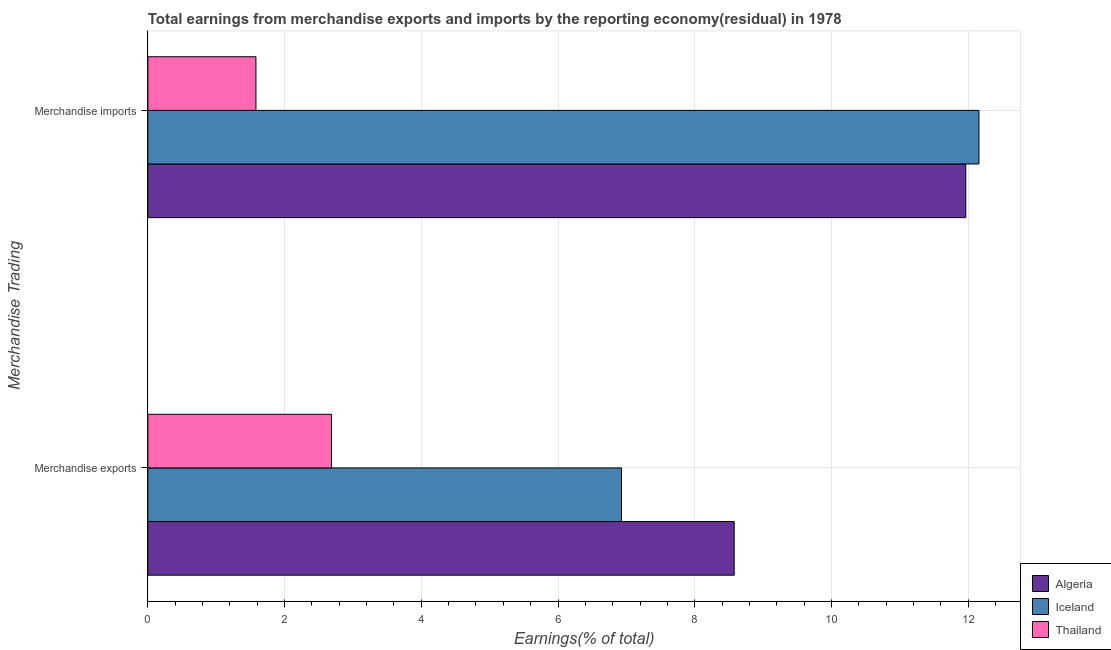How many groups of bars are there?
Give a very brief answer. 2. Are the number of bars per tick equal to the number of legend labels?
Provide a short and direct response. Yes. Are the number of bars on each tick of the Y-axis equal?
Give a very brief answer. Yes. What is the label of the 1st group of bars from the top?
Your answer should be compact. Merchandise imports. What is the earnings from merchandise exports in Algeria?
Offer a terse response. 8.58. Across all countries, what is the maximum earnings from merchandise imports?
Keep it short and to the point. 12.16. Across all countries, what is the minimum earnings from merchandise imports?
Your answer should be compact. 1.58. In which country was the earnings from merchandise imports maximum?
Your answer should be compact. Iceland. In which country was the earnings from merchandise imports minimum?
Ensure brevity in your answer.  Thailand. What is the total earnings from merchandise exports in the graph?
Offer a very short reply. 18.19. What is the difference between the earnings from merchandise imports in Iceland and that in Thailand?
Offer a terse response. 10.58. What is the difference between the earnings from merchandise exports in Thailand and the earnings from merchandise imports in Algeria?
Keep it short and to the point. -9.28. What is the average earnings from merchandise exports per country?
Your response must be concise. 6.06. What is the difference between the earnings from merchandise imports and earnings from merchandise exports in Algeria?
Provide a succinct answer. 3.39. In how many countries, is the earnings from merchandise exports greater than 0.4 %?
Make the answer very short. 3. What is the ratio of the earnings from merchandise exports in Thailand to that in Iceland?
Make the answer very short. 0.39. What does the 3rd bar from the top in Merchandise imports represents?
Your answer should be compact. Algeria. What does the 3rd bar from the bottom in Merchandise exports represents?
Your answer should be compact. Thailand. Are all the bars in the graph horizontal?
Your response must be concise. Yes. What is the difference between two consecutive major ticks on the X-axis?
Offer a very short reply. 2. Are the values on the major ticks of X-axis written in scientific E-notation?
Make the answer very short. No. Does the graph contain any zero values?
Your answer should be compact. No. Does the graph contain grids?
Your response must be concise. Yes. What is the title of the graph?
Give a very brief answer. Total earnings from merchandise exports and imports by the reporting economy(residual) in 1978. What is the label or title of the X-axis?
Your answer should be compact. Earnings(% of total). What is the label or title of the Y-axis?
Ensure brevity in your answer.  Merchandise Trading. What is the Earnings(% of total) in Algeria in Merchandise exports?
Offer a very short reply. 8.58. What is the Earnings(% of total) of Iceland in Merchandise exports?
Offer a very short reply. 6.93. What is the Earnings(% of total) in Thailand in Merchandise exports?
Your answer should be compact. 2.69. What is the Earnings(% of total) in Algeria in Merchandise imports?
Your answer should be very brief. 11.97. What is the Earnings(% of total) of Iceland in Merchandise imports?
Your answer should be very brief. 12.16. What is the Earnings(% of total) in Thailand in Merchandise imports?
Offer a very short reply. 1.58. Across all Merchandise Trading, what is the maximum Earnings(% of total) of Algeria?
Give a very brief answer. 11.97. Across all Merchandise Trading, what is the maximum Earnings(% of total) in Iceland?
Make the answer very short. 12.16. Across all Merchandise Trading, what is the maximum Earnings(% of total) of Thailand?
Offer a very short reply. 2.69. Across all Merchandise Trading, what is the minimum Earnings(% of total) of Algeria?
Give a very brief answer. 8.58. Across all Merchandise Trading, what is the minimum Earnings(% of total) of Iceland?
Make the answer very short. 6.93. Across all Merchandise Trading, what is the minimum Earnings(% of total) in Thailand?
Offer a terse response. 1.58. What is the total Earnings(% of total) in Algeria in the graph?
Offer a very short reply. 20.54. What is the total Earnings(% of total) of Iceland in the graph?
Ensure brevity in your answer.  19.09. What is the total Earnings(% of total) in Thailand in the graph?
Ensure brevity in your answer.  4.27. What is the difference between the Earnings(% of total) in Algeria in Merchandise exports and that in Merchandise imports?
Keep it short and to the point. -3.39. What is the difference between the Earnings(% of total) of Iceland in Merchandise exports and that in Merchandise imports?
Ensure brevity in your answer.  -5.23. What is the difference between the Earnings(% of total) in Thailand in Merchandise exports and that in Merchandise imports?
Keep it short and to the point. 1.1. What is the difference between the Earnings(% of total) of Algeria in Merchandise exports and the Earnings(% of total) of Iceland in Merchandise imports?
Offer a very short reply. -3.58. What is the difference between the Earnings(% of total) of Algeria in Merchandise exports and the Earnings(% of total) of Thailand in Merchandise imports?
Make the answer very short. 7. What is the difference between the Earnings(% of total) in Iceland in Merchandise exports and the Earnings(% of total) in Thailand in Merchandise imports?
Ensure brevity in your answer.  5.35. What is the average Earnings(% of total) of Algeria per Merchandise Trading?
Provide a short and direct response. 10.27. What is the average Earnings(% of total) in Iceland per Merchandise Trading?
Give a very brief answer. 9.54. What is the average Earnings(% of total) of Thailand per Merchandise Trading?
Your response must be concise. 2.13. What is the difference between the Earnings(% of total) of Algeria and Earnings(% of total) of Iceland in Merchandise exports?
Offer a terse response. 1.65. What is the difference between the Earnings(% of total) in Algeria and Earnings(% of total) in Thailand in Merchandise exports?
Ensure brevity in your answer.  5.89. What is the difference between the Earnings(% of total) in Iceland and Earnings(% of total) in Thailand in Merchandise exports?
Your answer should be very brief. 4.24. What is the difference between the Earnings(% of total) in Algeria and Earnings(% of total) in Iceland in Merchandise imports?
Your answer should be very brief. -0.19. What is the difference between the Earnings(% of total) of Algeria and Earnings(% of total) of Thailand in Merchandise imports?
Your answer should be very brief. 10.38. What is the difference between the Earnings(% of total) in Iceland and Earnings(% of total) in Thailand in Merchandise imports?
Your response must be concise. 10.58. What is the ratio of the Earnings(% of total) of Algeria in Merchandise exports to that in Merchandise imports?
Make the answer very short. 0.72. What is the ratio of the Earnings(% of total) in Iceland in Merchandise exports to that in Merchandise imports?
Offer a terse response. 0.57. What is the ratio of the Earnings(% of total) of Thailand in Merchandise exports to that in Merchandise imports?
Provide a short and direct response. 1.7. What is the difference between the highest and the second highest Earnings(% of total) of Algeria?
Offer a very short reply. 3.39. What is the difference between the highest and the second highest Earnings(% of total) of Iceland?
Your answer should be compact. 5.23. What is the difference between the highest and the second highest Earnings(% of total) in Thailand?
Keep it short and to the point. 1.1. What is the difference between the highest and the lowest Earnings(% of total) of Algeria?
Provide a short and direct response. 3.39. What is the difference between the highest and the lowest Earnings(% of total) in Iceland?
Keep it short and to the point. 5.23. What is the difference between the highest and the lowest Earnings(% of total) of Thailand?
Keep it short and to the point. 1.1. 